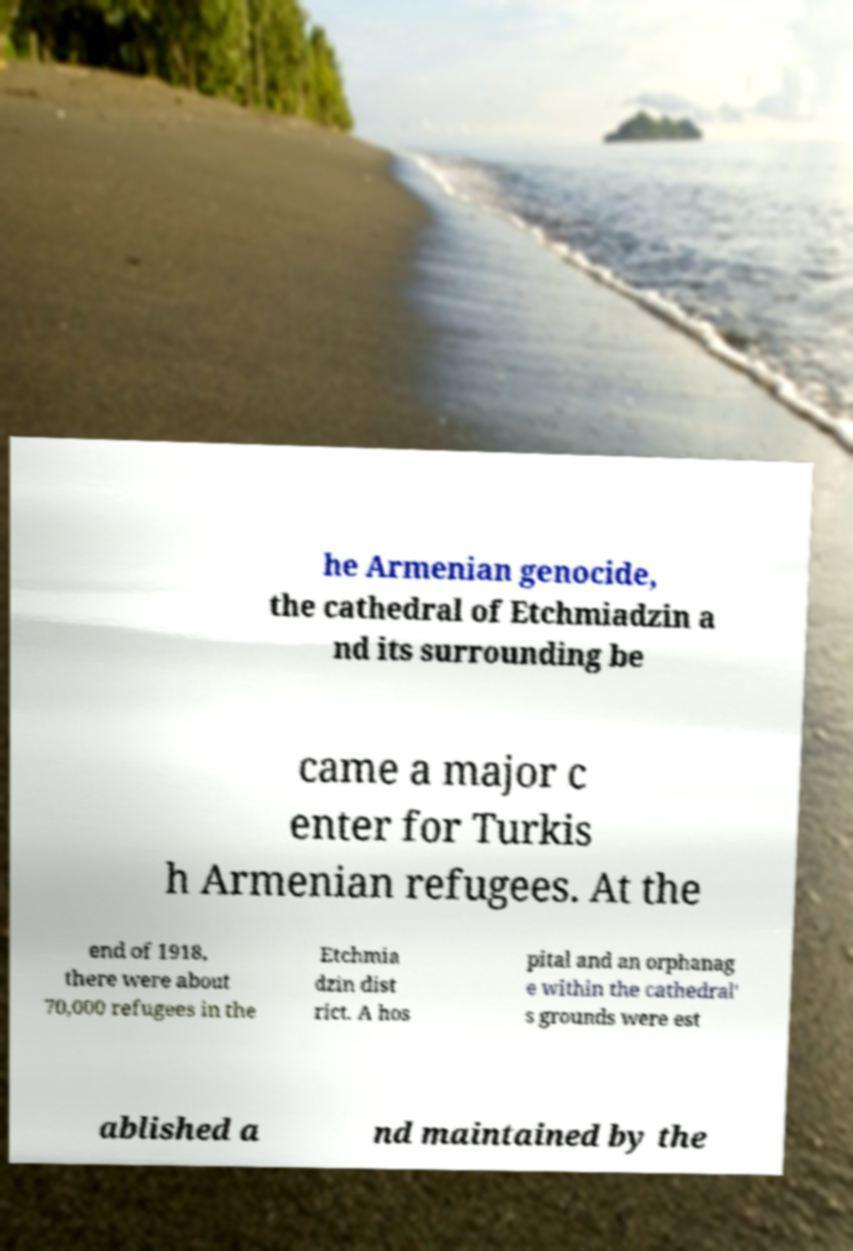Please read and relay the text visible in this image. What does it say? he Armenian genocide, the cathedral of Etchmiadzin a nd its surrounding be came a major c enter for Turkis h Armenian refugees. At the end of 1918, there were about 70,000 refugees in the Etchmia dzin dist rict. A hos pital and an orphanag e within the cathedral' s grounds were est ablished a nd maintained by the 